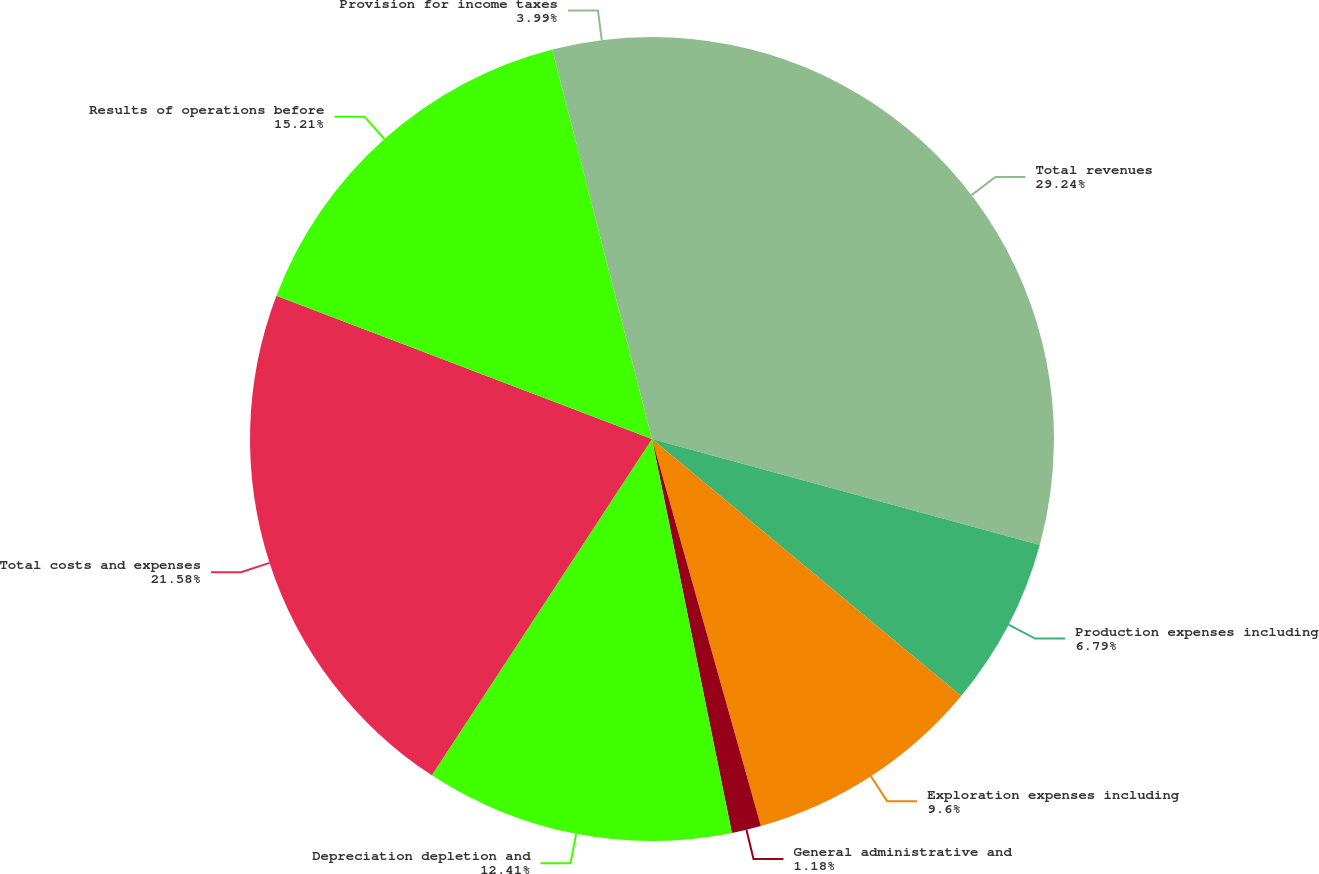<chart> <loc_0><loc_0><loc_500><loc_500><pie_chart><fcel>Total revenues<fcel>Production expenses including<fcel>Exploration expenses including<fcel>General administrative and<fcel>Depreciation depletion and<fcel>Total costs and expenses<fcel>Results of operations before<fcel>Provision for income taxes<nl><fcel>29.25%<fcel>6.79%<fcel>9.6%<fcel>1.18%<fcel>12.41%<fcel>21.58%<fcel>15.21%<fcel>3.99%<nl></chart> 